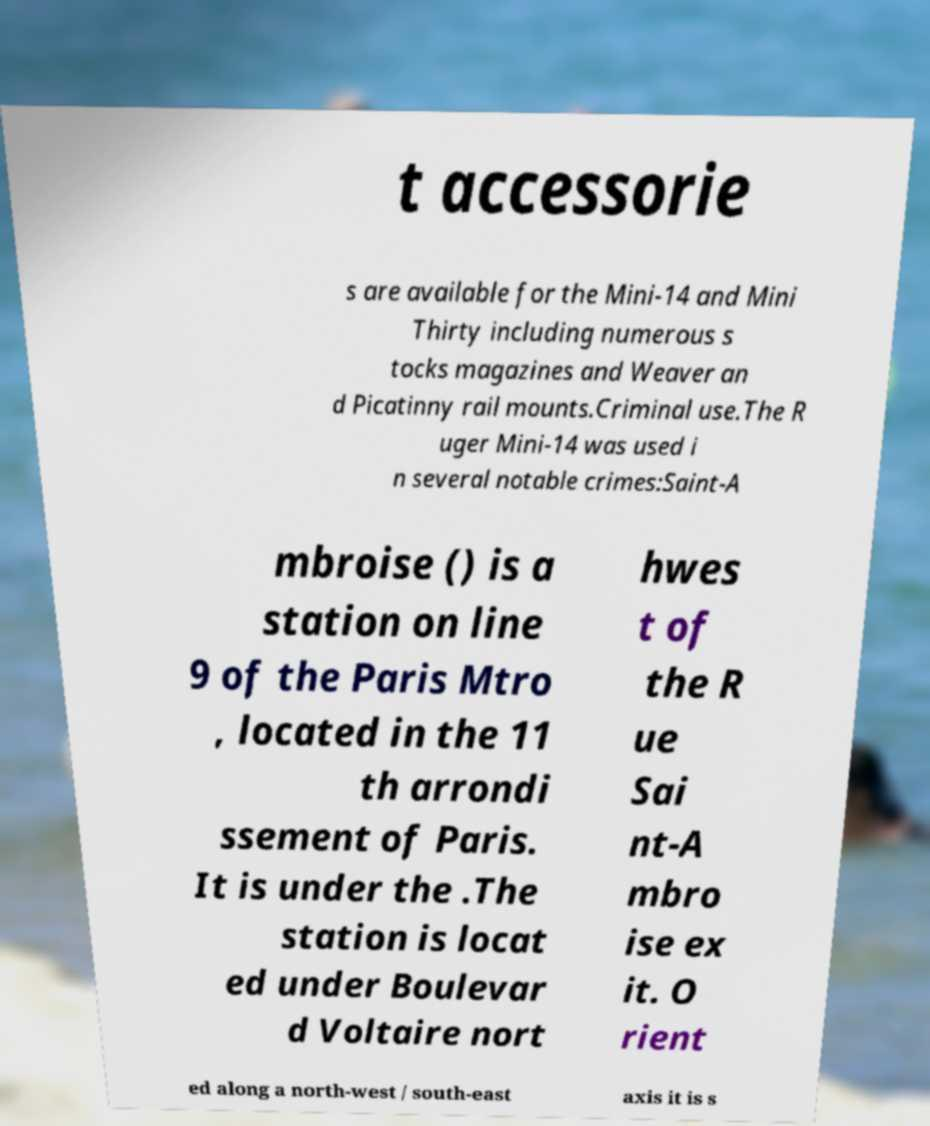For documentation purposes, I need the text within this image transcribed. Could you provide that? t accessorie s are available for the Mini-14 and Mini Thirty including numerous s tocks magazines and Weaver an d Picatinny rail mounts.Criminal use.The R uger Mini-14 was used i n several notable crimes:Saint-A mbroise () is a station on line 9 of the Paris Mtro , located in the 11 th arrondi ssement of Paris. It is under the .The station is locat ed under Boulevar d Voltaire nort hwes t of the R ue Sai nt-A mbro ise ex it. O rient ed along a north-west / south-east axis it is s 